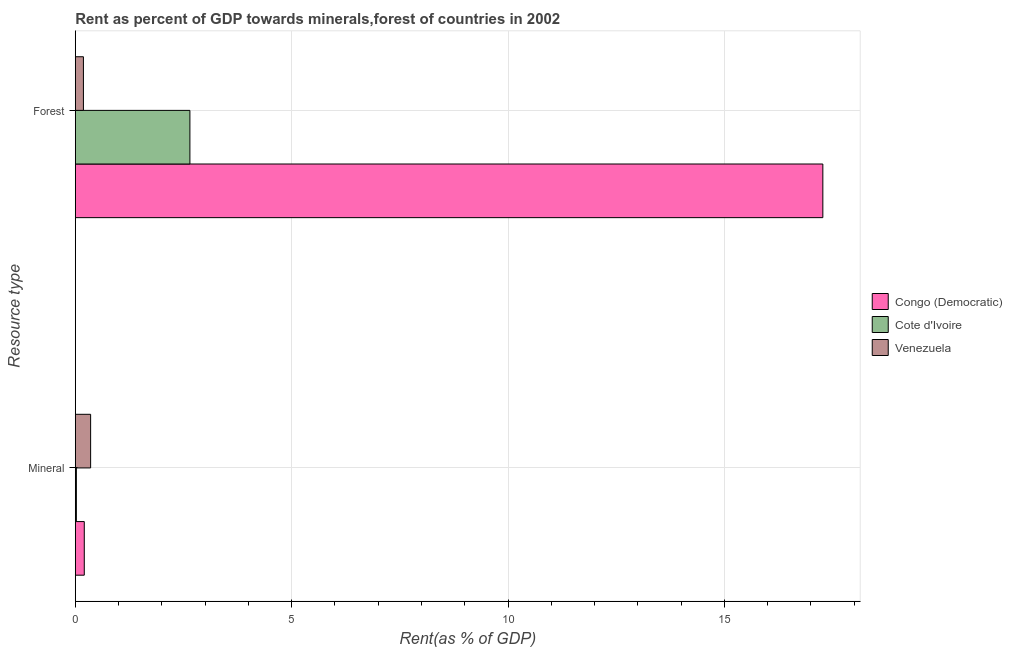Are the number of bars per tick equal to the number of legend labels?
Your response must be concise. Yes. Are the number of bars on each tick of the Y-axis equal?
Your response must be concise. Yes. How many bars are there on the 2nd tick from the bottom?
Keep it short and to the point. 3. What is the label of the 2nd group of bars from the top?
Make the answer very short. Mineral. What is the mineral rent in Congo (Democratic)?
Your response must be concise. 0.21. Across all countries, what is the maximum mineral rent?
Your answer should be very brief. 0.35. Across all countries, what is the minimum forest rent?
Your answer should be compact. 0.19. In which country was the forest rent maximum?
Ensure brevity in your answer.  Congo (Democratic). In which country was the forest rent minimum?
Give a very brief answer. Venezuela. What is the total forest rent in the graph?
Give a very brief answer. 20.11. What is the difference between the forest rent in Congo (Democratic) and that in Venezuela?
Make the answer very short. 17.09. What is the difference between the forest rent in Venezuela and the mineral rent in Congo (Democratic)?
Your answer should be very brief. -0.02. What is the average forest rent per country?
Your answer should be very brief. 6.7. What is the difference between the mineral rent and forest rent in Cote d'Ivoire?
Keep it short and to the point. -2.62. What is the ratio of the forest rent in Congo (Democratic) to that in Cote d'Ivoire?
Give a very brief answer. 6.52. Is the mineral rent in Cote d'Ivoire less than that in Congo (Democratic)?
Give a very brief answer. Yes. In how many countries, is the mineral rent greater than the average mineral rent taken over all countries?
Give a very brief answer. 2. What does the 2nd bar from the top in Forest represents?
Provide a short and direct response. Cote d'Ivoire. What does the 3rd bar from the bottom in Mineral represents?
Your answer should be compact. Venezuela. Are all the bars in the graph horizontal?
Ensure brevity in your answer.  Yes. How many countries are there in the graph?
Provide a succinct answer. 3. What is the difference between two consecutive major ticks on the X-axis?
Offer a terse response. 5. Does the graph contain grids?
Provide a short and direct response. Yes. Where does the legend appear in the graph?
Your answer should be compact. Center right. How many legend labels are there?
Your answer should be compact. 3. What is the title of the graph?
Your answer should be very brief. Rent as percent of GDP towards minerals,forest of countries in 2002. Does "Hungary" appear as one of the legend labels in the graph?
Keep it short and to the point. No. What is the label or title of the X-axis?
Your answer should be compact. Rent(as % of GDP). What is the label or title of the Y-axis?
Your answer should be compact. Resource type. What is the Rent(as % of GDP) of Congo (Democratic) in Mineral?
Make the answer very short. 0.21. What is the Rent(as % of GDP) in Cote d'Ivoire in Mineral?
Offer a very short reply. 0.02. What is the Rent(as % of GDP) of Venezuela in Mineral?
Your answer should be very brief. 0.35. What is the Rent(as % of GDP) of Congo (Democratic) in Forest?
Your answer should be very brief. 17.28. What is the Rent(as % of GDP) of Cote d'Ivoire in Forest?
Make the answer very short. 2.65. What is the Rent(as % of GDP) of Venezuela in Forest?
Provide a short and direct response. 0.19. Across all Resource type, what is the maximum Rent(as % of GDP) in Congo (Democratic)?
Make the answer very short. 17.28. Across all Resource type, what is the maximum Rent(as % of GDP) of Cote d'Ivoire?
Offer a very short reply. 2.65. Across all Resource type, what is the maximum Rent(as % of GDP) in Venezuela?
Provide a short and direct response. 0.35. Across all Resource type, what is the minimum Rent(as % of GDP) of Congo (Democratic)?
Your response must be concise. 0.21. Across all Resource type, what is the minimum Rent(as % of GDP) of Cote d'Ivoire?
Make the answer very short. 0.02. Across all Resource type, what is the minimum Rent(as % of GDP) in Venezuela?
Your response must be concise. 0.19. What is the total Rent(as % of GDP) of Congo (Democratic) in the graph?
Offer a terse response. 17.48. What is the total Rent(as % of GDP) in Cote d'Ivoire in the graph?
Offer a terse response. 2.67. What is the total Rent(as % of GDP) in Venezuela in the graph?
Offer a terse response. 0.54. What is the difference between the Rent(as % of GDP) in Congo (Democratic) in Mineral and that in Forest?
Keep it short and to the point. -17.07. What is the difference between the Rent(as % of GDP) in Cote d'Ivoire in Mineral and that in Forest?
Your response must be concise. -2.62. What is the difference between the Rent(as % of GDP) in Venezuela in Mineral and that in Forest?
Your answer should be very brief. 0.17. What is the difference between the Rent(as % of GDP) of Congo (Democratic) in Mineral and the Rent(as % of GDP) of Cote d'Ivoire in Forest?
Provide a succinct answer. -2.44. What is the difference between the Rent(as % of GDP) of Congo (Democratic) in Mineral and the Rent(as % of GDP) of Venezuela in Forest?
Give a very brief answer. 0.02. What is the difference between the Rent(as % of GDP) in Cote d'Ivoire in Mineral and the Rent(as % of GDP) in Venezuela in Forest?
Your response must be concise. -0.16. What is the average Rent(as % of GDP) of Congo (Democratic) per Resource type?
Provide a succinct answer. 8.74. What is the average Rent(as % of GDP) of Cote d'Ivoire per Resource type?
Give a very brief answer. 1.34. What is the average Rent(as % of GDP) in Venezuela per Resource type?
Your answer should be very brief. 0.27. What is the difference between the Rent(as % of GDP) of Congo (Democratic) and Rent(as % of GDP) of Cote d'Ivoire in Mineral?
Ensure brevity in your answer.  0.18. What is the difference between the Rent(as % of GDP) of Congo (Democratic) and Rent(as % of GDP) of Venezuela in Mineral?
Make the answer very short. -0.15. What is the difference between the Rent(as % of GDP) in Cote d'Ivoire and Rent(as % of GDP) in Venezuela in Mineral?
Offer a very short reply. -0.33. What is the difference between the Rent(as % of GDP) of Congo (Democratic) and Rent(as % of GDP) of Cote d'Ivoire in Forest?
Your response must be concise. 14.63. What is the difference between the Rent(as % of GDP) of Congo (Democratic) and Rent(as % of GDP) of Venezuela in Forest?
Offer a terse response. 17.09. What is the difference between the Rent(as % of GDP) in Cote d'Ivoire and Rent(as % of GDP) in Venezuela in Forest?
Provide a succinct answer. 2.46. What is the ratio of the Rent(as % of GDP) of Congo (Democratic) in Mineral to that in Forest?
Make the answer very short. 0.01. What is the ratio of the Rent(as % of GDP) in Cote d'Ivoire in Mineral to that in Forest?
Offer a very short reply. 0.01. What is the ratio of the Rent(as % of GDP) of Venezuela in Mineral to that in Forest?
Ensure brevity in your answer.  1.89. What is the difference between the highest and the second highest Rent(as % of GDP) in Congo (Democratic)?
Make the answer very short. 17.07. What is the difference between the highest and the second highest Rent(as % of GDP) in Cote d'Ivoire?
Ensure brevity in your answer.  2.62. What is the difference between the highest and the second highest Rent(as % of GDP) of Venezuela?
Provide a short and direct response. 0.17. What is the difference between the highest and the lowest Rent(as % of GDP) of Congo (Democratic)?
Offer a very short reply. 17.07. What is the difference between the highest and the lowest Rent(as % of GDP) of Cote d'Ivoire?
Offer a very short reply. 2.62. What is the difference between the highest and the lowest Rent(as % of GDP) of Venezuela?
Your response must be concise. 0.17. 